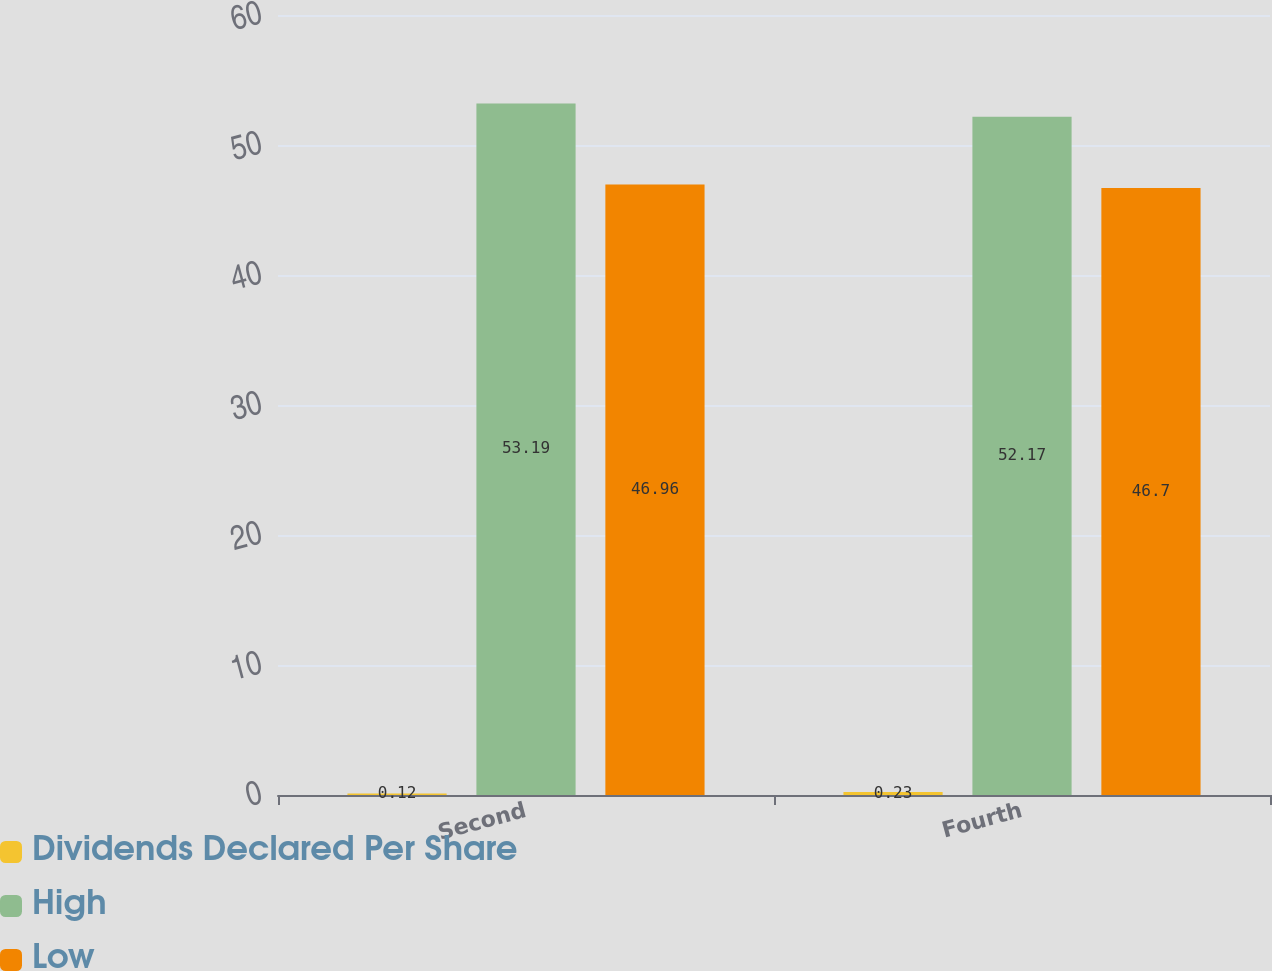Convert chart. <chart><loc_0><loc_0><loc_500><loc_500><stacked_bar_chart><ecel><fcel>Second<fcel>Fourth<nl><fcel>Dividends Declared Per Share<fcel>0.12<fcel>0.23<nl><fcel>High<fcel>53.19<fcel>52.17<nl><fcel>Low<fcel>46.96<fcel>46.7<nl></chart> 